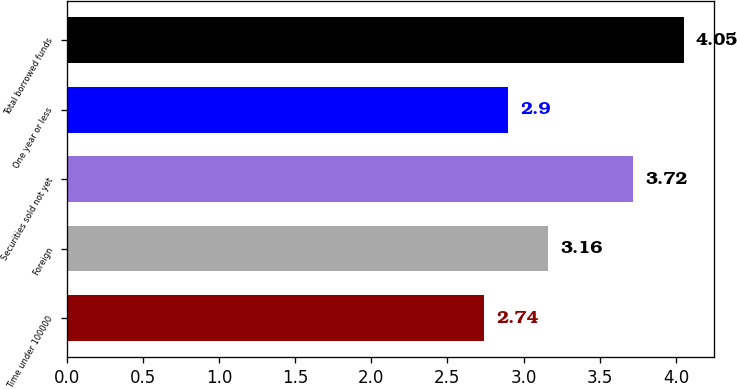Convert chart to OTSL. <chart><loc_0><loc_0><loc_500><loc_500><bar_chart><fcel>Time under 100000<fcel>Foreign<fcel>Securities sold not yet<fcel>One year or less<fcel>Total borrowed funds<nl><fcel>2.74<fcel>3.16<fcel>3.72<fcel>2.9<fcel>4.05<nl></chart> 